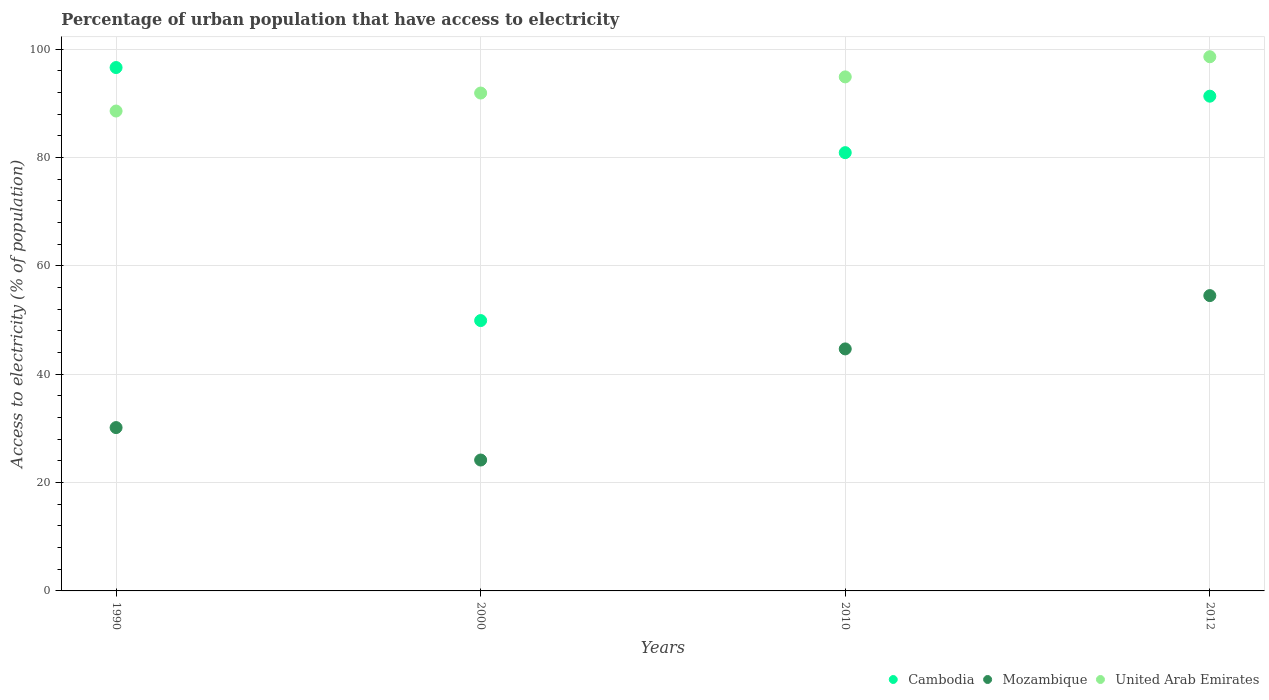What is the percentage of urban population that have access to electricity in Cambodia in 2012?
Your answer should be compact. 91.3. Across all years, what is the maximum percentage of urban population that have access to electricity in Cambodia?
Provide a short and direct response. 96.58. Across all years, what is the minimum percentage of urban population that have access to electricity in United Arab Emirates?
Your answer should be very brief. 88.56. In which year was the percentage of urban population that have access to electricity in Mozambique minimum?
Give a very brief answer. 2000. What is the total percentage of urban population that have access to electricity in Cambodia in the graph?
Keep it short and to the point. 318.65. What is the difference between the percentage of urban population that have access to electricity in Cambodia in 1990 and that in 2000?
Give a very brief answer. 46.69. What is the difference between the percentage of urban population that have access to electricity in Cambodia in 1990 and the percentage of urban population that have access to electricity in Mozambique in 2000?
Your answer should be very brief. 72.43. What is the average percentage of urban population that have access to electricity in Cambodia per year?
Offer a very short reply. 79.66. In the year 1990, what is the difference between the percentage of urban population that have access to electricity in Cambodia and percentage of urban population that have access to electricity in Mozambique?
Your response must be concise. 66.44. In how many years, is the percentage of urban population that have access to electricity in Cambodia greater than 72 %?
Ensure brevity in your answer.  3. What is the ratio of the percentage of urban population that have access to electricity in Cambodia in 1990 to that in 2000?
Make the answer very short. 1.94. Is the percentage of urban population that have access to electricity in Mozambique in 2000 less than that in 2012?
Your answer should be compact. Yes. What is the difference between the highest and the second highest percentage of urban population that have access to electricity in United Arab Emirates?
Keep it short and to the point. 3.72. What is the difference between the highest and the lowest percentage of urban population that have access to electricity in Mozambique?
Provide a succinct answer. 30.34. In how many years, is the percentage of urban population that have access to electricity in Mozambique greater than the average percentage of urban population that have access to electricity in Mozambique taken over all years?
Offer a terse response. 2. Is the sum of the percentage of urban population that have access to electricity in United Arab Emirates in 1990 and 2010 greater than the maximum percentage of urban population that have access to electricity in Mozambique across all years?
Your answer should be compact. Yes. Is the percentage of urban population that have access to electricity in Cambodia strictly less than the percentage of urban population that have access to electricity in Mozambique over the years?
Your answer should be compact. No. How many dotlines are there?
Keep it short and to the point. 3. How many years are there in the graph?
Your answer should be very brief. 4. Are the values on the major ticks of Y-axis written in scientific E-notation?
Make the answer very short. No. What is the title of the graph?
Provide a short and direct response. Percentage of urban population that have access to electricity. What is the label or title of the X-axis?
Make the answer very short. Years. What is the label or title of the Y-axis?
Keep it short and to the point. Access to electricity (% of population). What is the Access to electricity (% of population) in Cambodia in 1990?
Provide a succinct answer. 96.58. What is the Access to electricity (% of population) of Mozambique in 1990?
Keep it short and to the point. 30.14. What is the Access to electricity (% of population) in United Arab Emirates in 1990?
Provide a short and direct response. 88.56. What is the Access to electricity (% of population) in Cambodia in 2000?
Give a very brief answer. 49.89. What is the Access to electricity (% of population) in Mozambique in 2000?
Your answer should be very brief. 24.16. What is the Access to electricity (% of population) of United Arab Emirates in 2000?
Provide a succinct answer. 91.88. What is the Access to electricity (% of population) in Cambodia in 2010?
Ensure brevity in your answer.  80.88. What is the Access to electricity (% of population) in Mozambique in 2010?
Offer a terse response. 44.66. What is the Access to electricity (% of population) in United Arab Emirates in 2010?
Keep it short and to the point. 94.86. What is the Access to electricity (% of population) of Cambodia in 2012?
Provide a succinct answer. 91.3. What is the Access to electricity (% of population) of Mozambique in 2012?
Offer a very short reply. 54.5. What is the Access to electricity (% of population) in United Arab Emirates in 2012?
Offer a very short reply. 98.58. Across all years, what is the maximum Access to electricity (% of population) of Cambodia?
Your answer should be compact. 96.58. Across all years, what is the maximum Access to electricity (% of population) in Mozambique?
Offer a terse response. 54.5. Across all years, what is the maximum Access to electricity (% of population) in United Arab Emirates?
Ensure brevity in your answer.  98.58. Across all years, what is the minimum Access to electricity (% of population) of Cambodia?
Your response must be concise. 49.89. Across all years, what is the minimum Access to electricity (% of population) in Mozambique?
Provide a short and direct response. 24.16. Across all years, what is the minimum Access to electricity (% of population) of United Arab Emirates?
Ensure brevity in your answer.  88.56. What is the total Access to electricity (% of population) in Cambodia in the graph?
Make the answer very short. 318.65. What is the total Access to electricity (% of population) of Mozambique in the graph?
Make the answer very short. 153.46. What is the total Access to electricity (% of population) in United Arab Emirates in the graph?
Offer a terse response. 373.87. What is the difference between the Access to electricity (% of population) in Cambodia in 1990 and that in 2000?
Make the answer very short. 46.69. What is the difference between the Access to electricity (% of population) in Mozambique in 1990 and that in 2000?
Give a very brief answer. 5.99. What is the difference between the Access to electricity (% of population) in United Arab Emirates in 1990 and that in 2000?
Provide a succinct answer. -3.32. What is the difference between the Access to electricity (% of population) of Cambodia in 1990 and that in 2010?
Keep it short and to the point. 15.71. What is the difference between the Access to electricity (% of population) of Mozambique in 1990 and that in 2010?
Make the answer very short. -14.52. What is the difference between the Access to electricity (% of population) in United Arab Emirates in 1990 and that in 2010?
Your answer should be compact. -6.3. What is the difference between the Access to electricity (% of population) in Cambodia in 1990 and that in 2012?
Your response must be concise. 5.28. What is the difference between the Access to electricity (% of population) of Mozambique in 1990 and that in 2012?
Keep it short and to the point. -24.36. What is the difference between the Access to electricity (% of population) of United Arab Emirates in 1990 and that in 2012?
Offer a terse response. -10.02. What is the difference between the Access to electricity (% of population) of Cambodia in 2000 and that in 2010?
Offer a terse response. -30.99. What is the difference between the Access to electricity (% of population) in Mozambique in 2000 and that in 2010?
Ensure brevity in your answer.  -20.5. What is the difference between the Access to electricity (% of population) of United Arab Emirates in 2000 and that in 2010?
Keep it short and to the point. -2.98. What is the difference between the Access to electricity (% of population) in Cambodia in 2000 and that in 2012?
Your response must be concise. -41.41. What is the difference between the Access to electricity (% of population) of Mozambique in 2000 and that in 2012?
Offer a very short reply. -30.34. What is the difference between the Access to electricity (% of population) in United Arab Emirates in 2000 and that in 2012?
Offer a very short reply. -6.7. What is the difference between the Access to electricity (% of population) in Cambodia in 2010 and that in 2012?
Your answer should be very brief. -10.42. What is the difference between the Access to electricity (% of population) in Mozambique in 2010 and that in 2012?
Your response must be concise. -9.84. What is the difference between the Access to electricity (% of population) of United Arab Emirates in 2010 and that in 2012?
Keep it short and to the point. -3.72. What is the difference between the Access to electricity (% of population) in Cambodia in 1990 and the Access to electricity (% of population) in Mozambique in 2000?
Your response must be concise. 72.43. What is the difference between the Access to electricity (% of population) in Cambodia in 1990 and the Access to electricity (% of population) in United Arab Emirates in 2000?
Your answer should be very brief. 4.71. What is the difference between the Access to electricity (% of population) in Mozambique in 1990 and the Access to electricity (% of population) in United Arab Emirates in 2000?
Your answer should be compact. -61.74. What is the difference between the Access to electricity (% of population) of Cambodia in 1990 and the Access to electricity (% of population) of Mozambique in 2010?
Ensure brevity in your answer.  51.92. What is the difference between the Access to electricity (% of population) of Cambodia in 1990 and the Access to electricity (% of population) of United Arab Emirates in 2010?
Ensure brevity in your answer.  1.73. What is the difference between the Access to electricity (% of population) in Mozambique in 1990 and the Access to electricity (% of population) in United Arab Emirates in 2010?
Give a very brief answer. -64.72. What is the difference between the Access to electricity (% of population) of Cambodia in 1990 and the Access to electricity (% of population) of Mozambique in 2012?
Your response must be concise. 42.08. What is the difference between the Access to electricity (% of population) of Cambodia in 1990 and the Access to electricity (% of population) of United Arab Emirates in 2012?
Ensure brevity in your answer.  -1.99. What is the difference between the Access to electricity (% of population) in Mozambique in 1990 and the Access to electricity (% of population) in United Arab Emirates in 2012?
Your answer should be compact. -68.44. What is the difference between the Access to electricity (% of population) of Cambodia in 2000 and the Access to electricity (% of population) of Mozambique in 2010?
Offer a very short reply. 5.23. What is the difference between the Access to electricity (% of population) of Cambodia in 2000 and the Access to electricity (% of population) of United Arab Emirates in 2010?
Offer a terse response. -44.97. What is the difference between the Access to electricity (% of population) in Mozambique in 2000 and the Access to electricity (% of population) in United Arab Emirates in 2010?
Make the answer very short. -70.7. What is the difference between the Access to electricity (% of population) of Cambodia in 2000 and the Access to electricity (% of population) of Mozambique in 2012?
Your response must be concise. -4.61. What is the difference between the Access to electricity (% of population) of Cambodia in 2000 and the Access to electricity (% of population) of United Arab Emirates in 2012?
Provide a short and direct response. -48.69. What is the difference between the Access to electricity (% of population) of Mozambique in 2000 and the Access to electricity (% of population) of United Arab Emirates in 2012?
Your response must be concise. -74.42. What is the difference between the Access to electricity (% of population) of Cambodia in 2010 and the Access to electricity (% of population) of Mozambique in 2012?
Keep it short and to the point. 26.38. What is the difference between the Access to electricity (% of population) of Cambodia in 2010 and the Access to electricity (% of population) of United Arab Emirates in 2012?
Offer a terse response. -17.7. What is the difference between the Access to electricity (% of population) of Mozambique in 2010 and the Access to electricity (% of population) of United Arab Emirates in 2012?
Your answer should be very brief. -53.92. What is the average Access to electricity (% of population) in Cambodia per year?
Offer a terse response. 79.66. What is the average Access to electricity (% of population) in Mozambique per year?
Give a very brief answer. 38.37. What is the average Access to electricity (% of population) of United Arab Emirates per year?
Give a very brief answer. 93.47. In the year 1990, what is the difference between the Access to electricity (% of population) in Cambodia and Access to electricity (% of population) in Mozambique?
Your answer should be very brief. 66.44. In the year 1990, what is the difference between the Access to electricity (% of population) in Cambodia and Access to electricity (% of population) in United Arab Emirates?
Offer a very short reply. 8.03. In the year 1990, what is the difference between the Access to electricity (% of population) of Mozambique and Access to electricity (% of population) of United Arab Emirates?
Provide a short and direct response. -58.42. In the year 2000, what is the difference between the Access to electricity (% of population) in Cambodia and Access to electricity (% of population) in Mozambique?
Your answer should be compact. 25.73. In the year 2000, what is the difference between the Access to electricity (% of population) in Cambodia and Access to electricity (% of population) in United Arab Emirates?
Ensure brevity in your answer.  -41.99. In the year 2000, what is the difference between the Access to electricity (% of population) of Mozambique and Access to electricity (% of population) of United Arab Emirates?
Provide a succinct answer. -67.72. In the year 2010, what is the difference between the Access to electricity (% of population) in Cambodia and Access to electricity (% of population) in Mozambique?
Your answer should be very brief. 36.22. In the year 2010, what is the difference between the Access to electricity (% of population) in Cambodia and Access to electricity (% of population) in United Arab Emirates?
Provide a short and direct response. -13.98. In the year 2010, what is the difference between the Access to electricity (% of population) of Mozambique and Access to electricity (% of population) of United Arab Emirates?
Your answer should be compact. -50.2. In the year 2012, what is the difference between the Access to electricity (% of population) in Cambodia and Access to electricity (% of population) in Mozambique?
Keep it short and to the point. 36.8. In the year 2012, what is the difference between the Access to electricity (% of population) of Cambodia and Access to electricity (% of population) of United Arab Emirates?
Offer a terse response. -7.28. In the year 2012, what is the difference between the Access to electricity (% of population) of Mozambique and Access to electricity (% of population) of United Arab Emirates?
Your answer should be very brief. -44.08. What is the ratio of the Access to electricity (% of population) of Cambodia in 1990 to that in 2000?
Keep it short and to the point. 1.94. What is the ratio of the Access to electricity (% of population) of Mozambique in 1990 to that in 2000?
Your response must be concise. 1.25. What is the ratio of the Access to electricity (% of population) of United Arab Emirates in 1990 to that in 2000?
Ensure brevity in your answer.  0.96. What is the ratio of the Access to electricity (% of population) of Cambodia in 1990 to that in 2010?
Provide a succinct answer. 1.19. What is the ratio of the Access to electricity (% of population) of Mozambique in 1990 to that in 2010?
Offer a terse response. 0.67. What is the ratio of the Access to electricity (% of population) in United Arab Emirates in 1990 to that in 2010?
Provide a succinct answer. 0.93. What is the ratio of the Access to electricity (% of population) in Cambodia in 1990 to that in 2012?
Your response must be concise. 1.06. What is the ratio of the Access to electricity (% of population) of Mozambique in 1990 to that in 2012?
Your answer should be compact. 0.55. What is the ratio of the Access to electricity (% of population) in United Arab Emirates in 1990 to that in 2012?
Give a very brief answer. 0.9. What is the ratio of the Access to electricity (% of population) in Cambodia in 2000 to that in 2010?
Your response must be concise. 0.62. What is the ratio of the Access to electricity (% of population) in Mozambique in 2000 to that in 2010?
Your response must be concise. 0.54. What is the ratio of the Access to electricity (% of population) of United Arab Emirates in 2000 to that in 2010?
Make the answer very short. 0.97. What is the ratio of the Access to electricity (% of population) of Cambodia in 2000 to that in 2012?
Your answer should be very brief. 0.55. What is the ratio of the Access to electricity (% of population) in Mozambique in 2000 to that in 2012?
Make the answer very short. 0.44. What is the ratio of the Access to electricity (% of population) of United Arab Emirates in 2000 to that in 2012?
Your answer should be very brief. 0.93. What is the ratio of the Access to electricity (% of population) of Cambodia in 2010 to that in 2012?
Offer a terse response. 0.89. What is the ratio of the Access to electricity (% of population) in Mozambique in 2010 to that in 2012?
Make the answer very short. 0.82. What is the ratio of the Access to electricity (% of population) of United Arab Emirates in 2010 to that in 2012?
Provide a short and direct response. 0.96. What is the difference between the highest and the second highest Access to electricity (% of population) of Cambodia?
Provide a succinct answer. 5.28. What is the difference between the highest and the second highest Access to electricity (% of population) in Mozambique?
Offer a terse response. 9.84. What is the difference between the highest and the second highest Access to electricity (% of population) of United Arab Emirates?
Provide a succinct answer. 3.72. What is the difference between the highest and the lowest Access to electricity (% of population) of Cambodia?
Your response must be concise. 46.69. What is the difference between the highest and the lowest Access to electricity (% of population) in Mozambique?
Your answer should be compact. 30.34. What is the difference between the highest and the lowest Access to electricity (% of population) in United Arab Emirates?
Give a very brief answer. 10.02. 